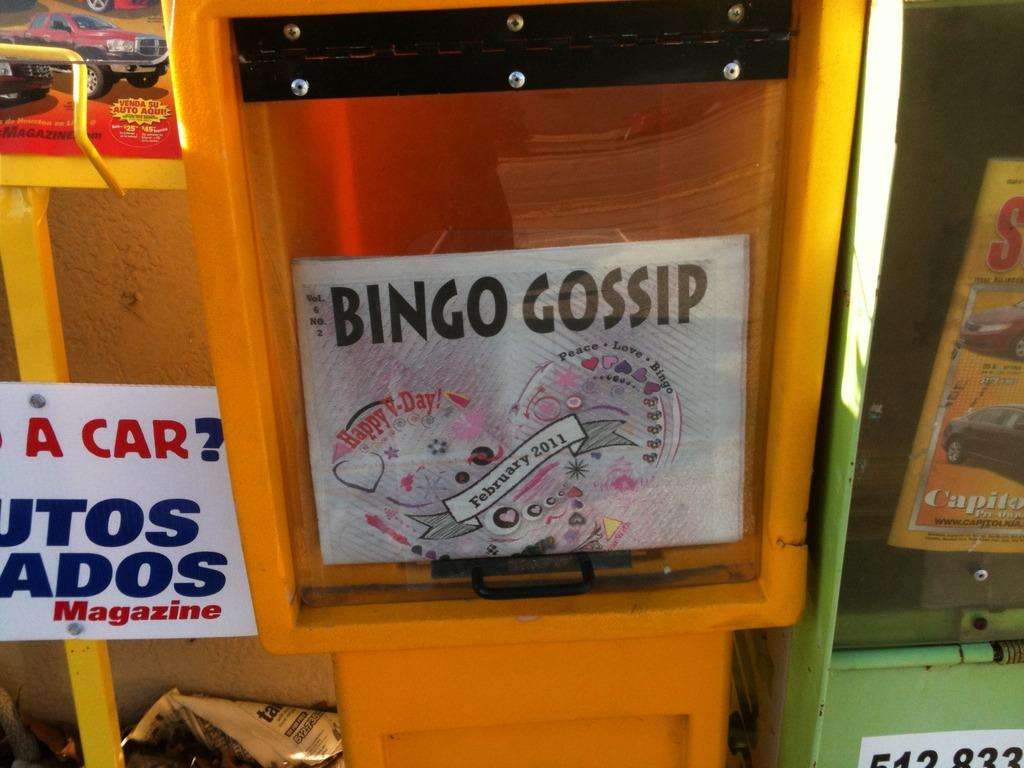What is on the board that is visible in the image? There is a board with text in the image. What other items can be seen in the image besides the board? There are posters and papers in the image. How does the spoon interact with the liquid in the image? There is no spoon or liquid present in the image. 